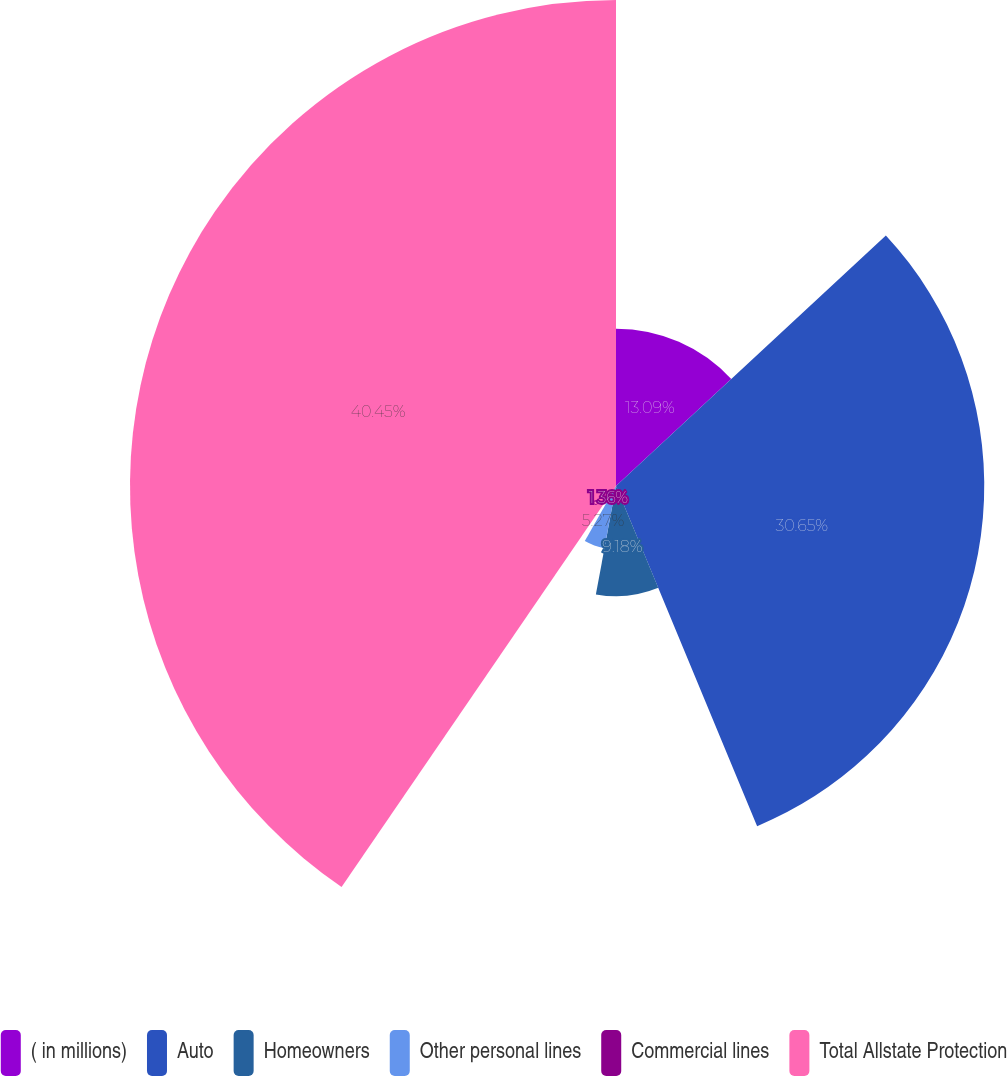Convert chart to OTSL. <chart><loc_0><loc_0><loc_500><loc_500><pie_chart><fcel>( in millions)<fcel>Auto<fcel>Homeowners<fcel>Other personal lines<fcel>Commercial lines<fcel>Total Allstate Protection<nl><fcel>13.09%<fcel>30.65%<fcel>9.18%<fcel>5.27%<fcel>1.36%<fcel>40.45%<nl></chart> 